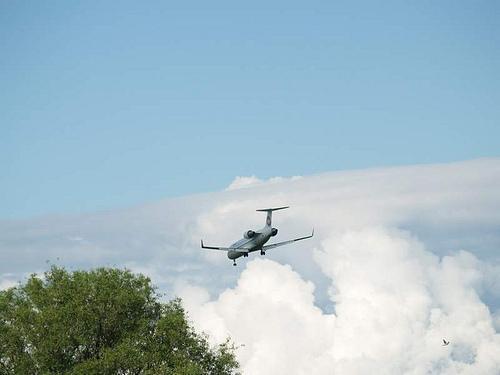How many planes are there?
Give a very brief answer. 1. 